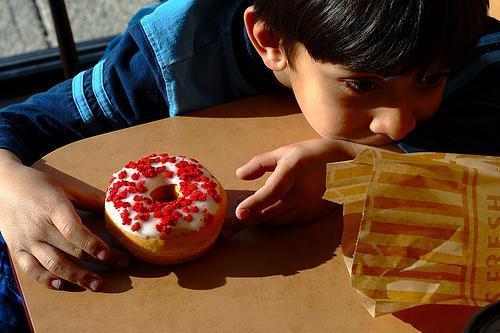How many doughnuts are there?
Give a very brief answer. 1. 